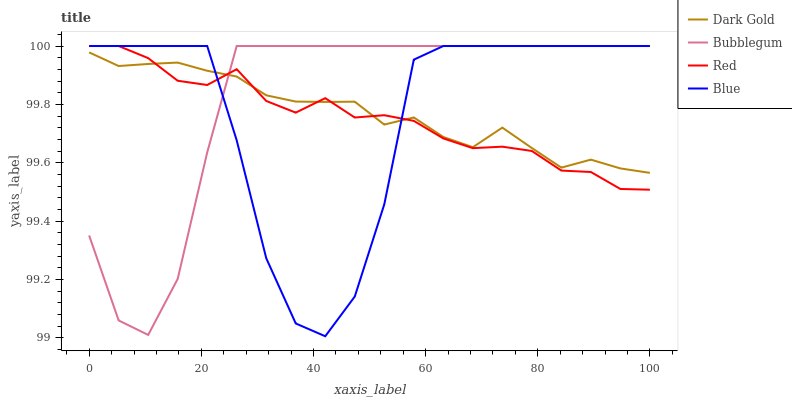Does Red have the minimum area under the curve?
Answer yes or no. Yes. Does Bubblegum have the maximum area under the curve?
Answer yes or no. Yes. Does Bubblegum have the minimum area under the curve?
Answer yes or no. No. Does Red have the maximum area under the curve?
Answer yes or no. No. Is Dark Gold the smoothest?
Answer yes or no. Yes. Is Blue the roughest?
Answer yes or no. Yes. Is Red the smoothest?
Answer yes or no. No. Is Red the roughest?
Answer yes or no. No. Does Blue have the lowest value?
Answer yes or no. Yes. Does Red have the lowest value?
Answer yes or no. No. Does Bubblegum have the highest value?
Answer yes or no. Yes. Does Dark Gold have the highest value?
Answer yes or no. No. Does Dark Gold intersect Red?
Answer yes or no. Yes. Is Dark Gold less than Red?
Answer yes or no. No. Is Dark Gold greater than Red?
Answer yes or no. No. 